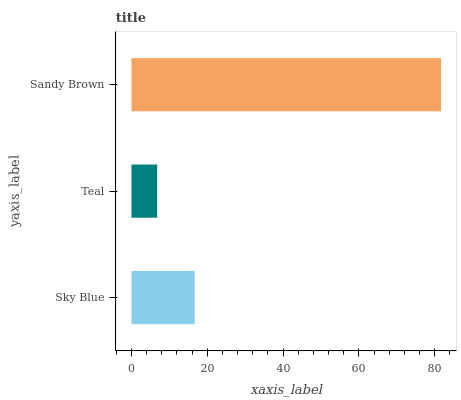Is Teal the minimum?
Answer yes or no. Yes. Is Sandy Brown the maximum?
Answer yes or no. Yes. Is Sandy Brown the minimum?
Answer yes or no. No. Is Teal the maximum?
Answer yes or no. No. Is Sandy Brown greater than Teal?
Answer yes or no. Yes. Is Teal less than Sandy Brown?
Answer yes or no. Yes. Is Teal greater than Sandy Brown?
Answer yes or no. No. Is Sandy Brown less than Teal?
Answer yes or no. No. Is Sky Blue the high median?
Answer yes or no. Yes. Is Sky Blue the low median?
Answer yes or no. Yes. Is Sandy Brown the high median?
Answer yes or no. No. Is Teal the low median?
Answer yes or no. No. 